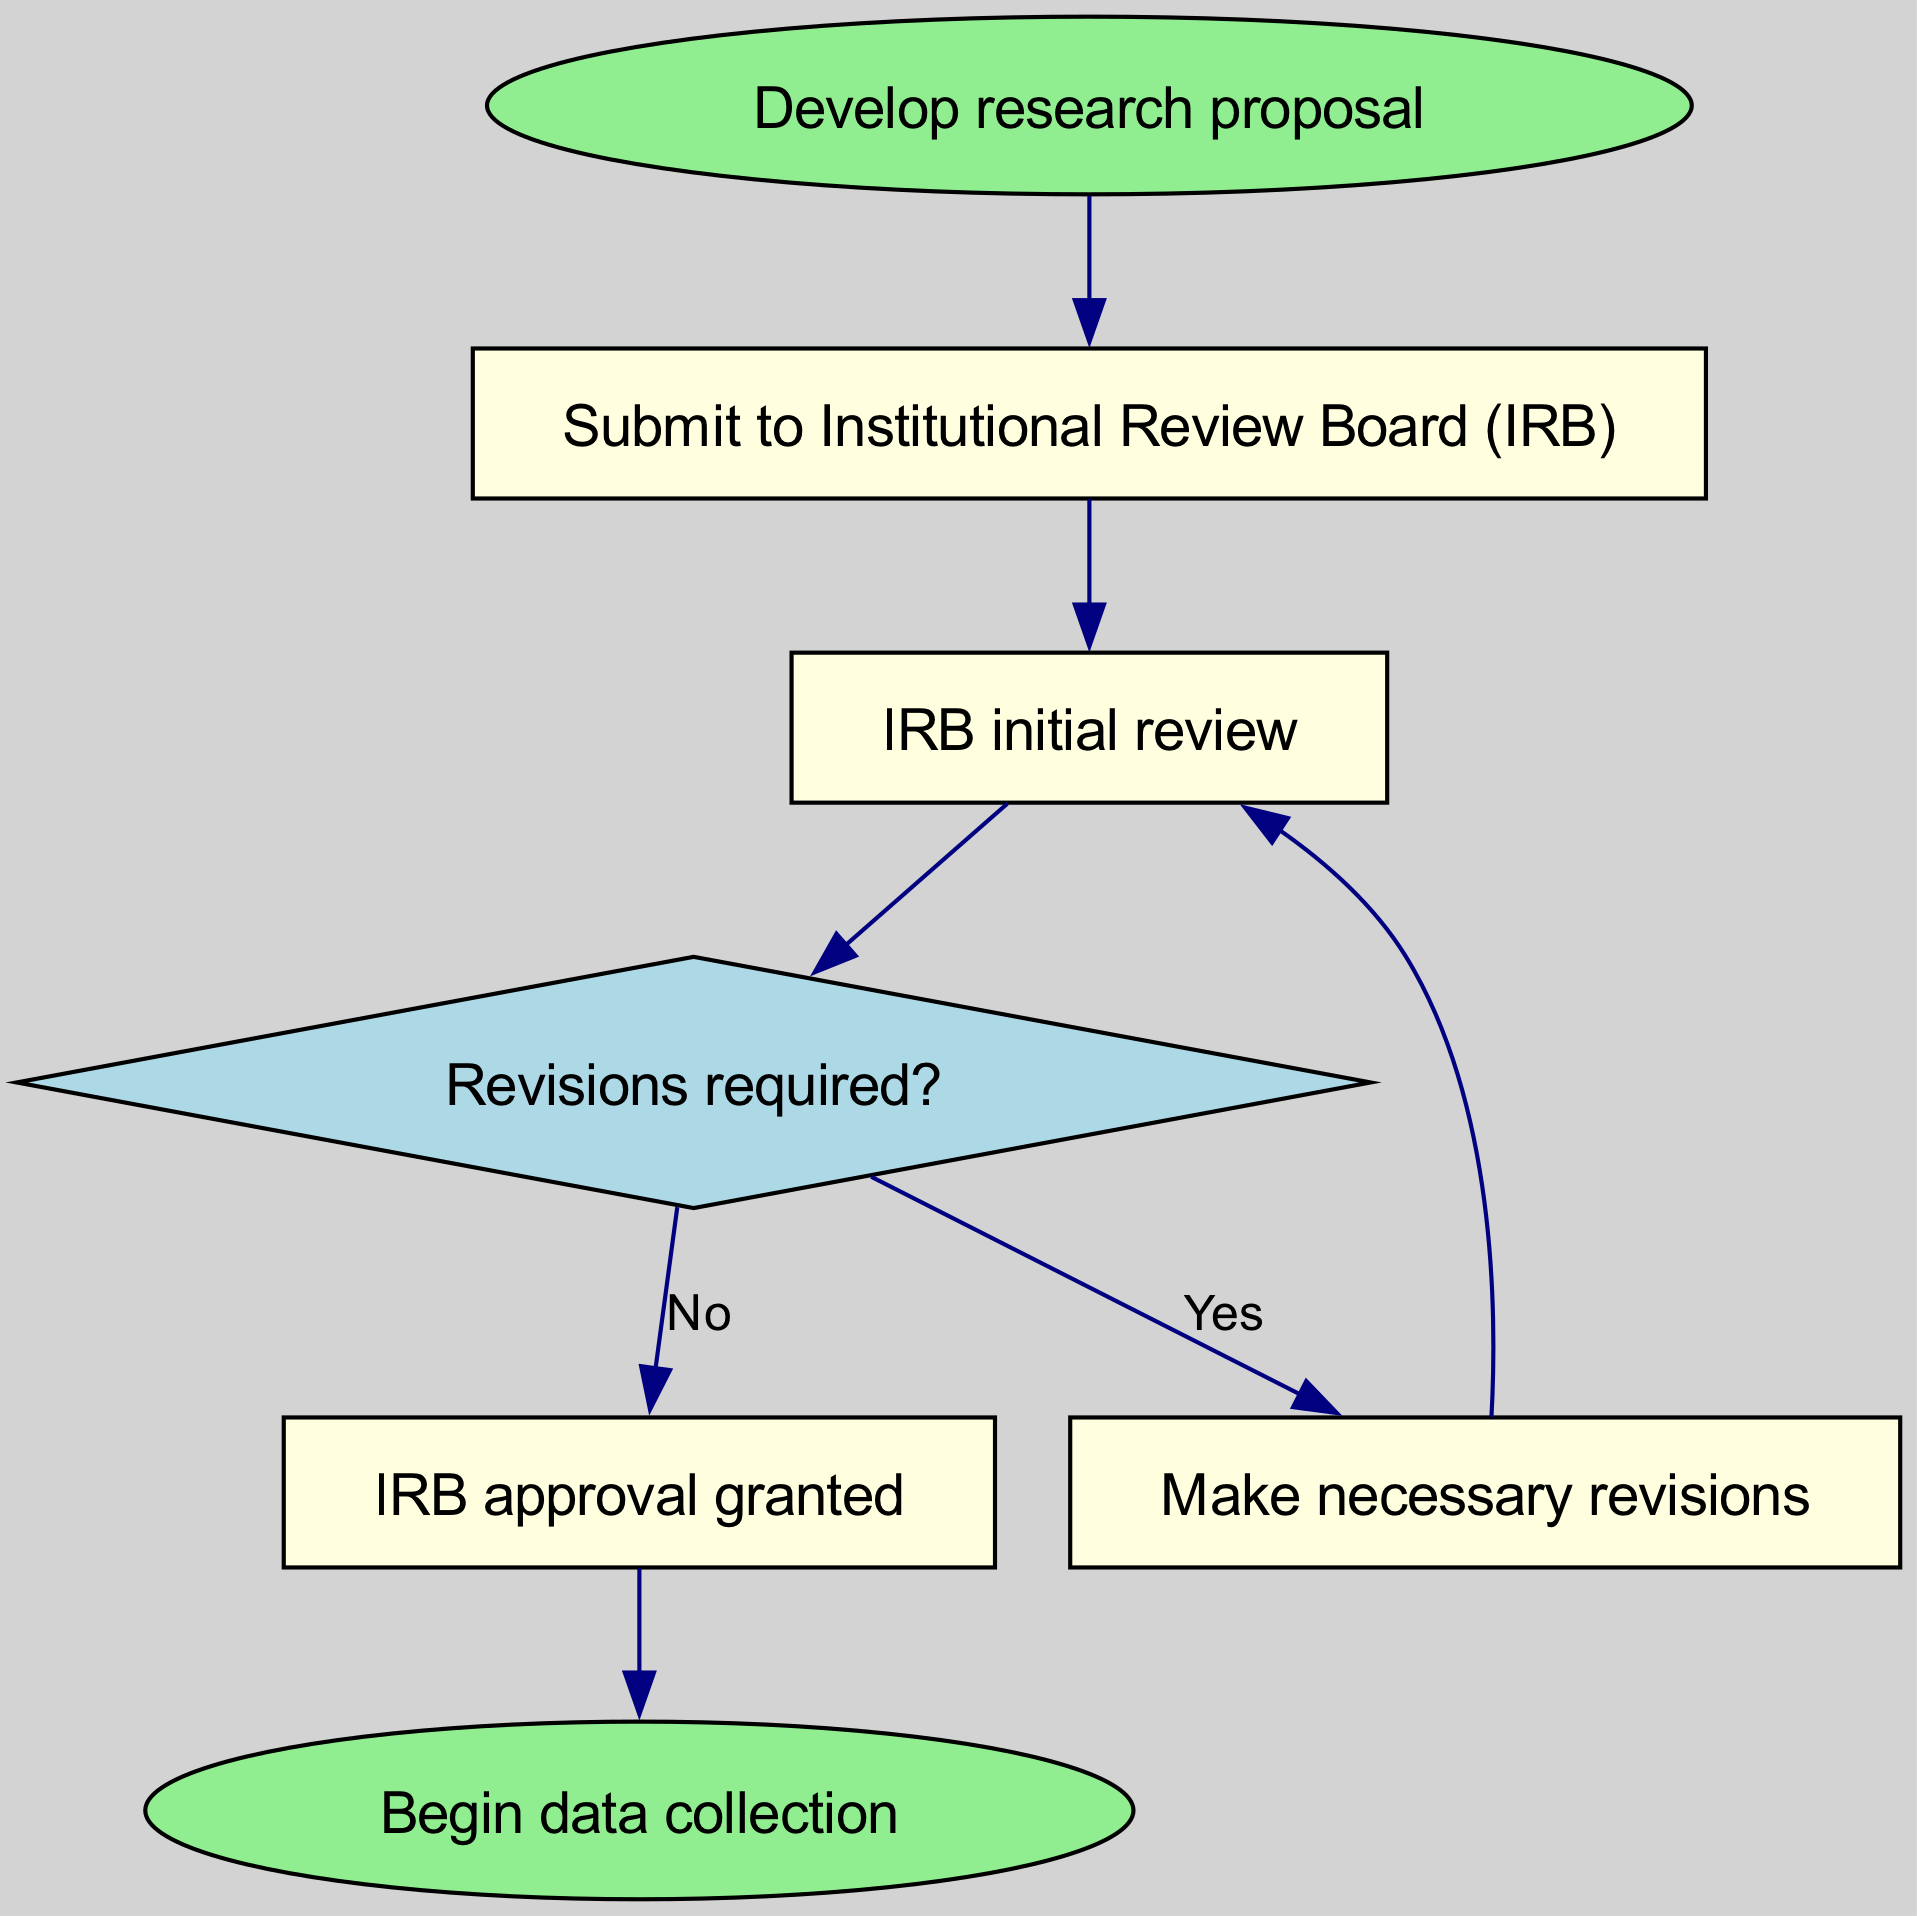What is the first step in the diagram? The first step in the flowchart is represented by the node with the text "Develop research proposal." This is the initial action that needs to be taken before moving forward to the next steps.
Answer: Develop research proposal How many nodes are present in the diagram? The diagram consists of 7 nodes, which include the start, decision, and end points. Each node represents a distinct step or action in the ethical review process.
Answer: 7 What happens after the IRB initial review? After the IRB initial review, a decision is made as indicated by the diamond-shaped node asking "Revisions required?" This node leads to either making revisions or granting approval.
Answer: Revisions required? What is the decision made at node 4? Node 4, labeled "Revisions required?", is a decision point that offers two potential outcomes: If revisions are needed, the process flows to node 5; if not, it proceeds to node 6 for approval.
Answer: Yes or No What comes after IRB approval is granted? According to the flowchart, after the IRB approval is granted (node 6), the next step indicated is "Begin data collection" (node 7). This follows the successful completion of the review and approval process.
Answer: Begin data collection If revisions are required, how does one proceed? If revisions are required as indicated by the decision at node 4, the flowchart directs one to node 5, which states "Make necessary revisions." After making the revisions, the process circles back to node 3 for another initial review.
Answer: Make necessary revisions What shape is used for the decision node in the diagram? The decision node in the diagram is represented as a diamond shape, which is a common convention in flowcharts to denote a point where a decision must be made.
Answer: Diamond How does the flowchart indicate the process continues after revisions are made? The flowchart indicates that after revisions are made (node 5), the process continues by connecting back to the IRB initial review (node 3). This loop shows that the process must be reassessed following any alterations.
Answer: Back to IRB initial review 